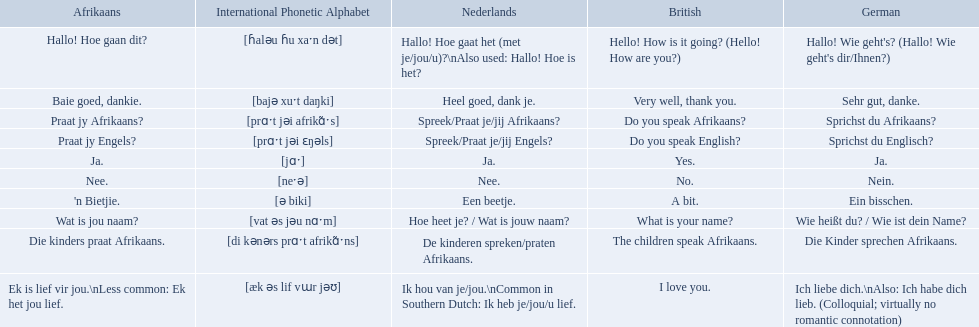What are the listed afrikaans phrases? Hallo! Hoe gaan dit?, Baie goed, dankie., Praat jy Afrikaans?, Praat jy Engels?, Ja., Nee., 'n Bietjie., Wat is jou naam?, Die kinders praat Afrikaans., Ek is lief vir jou.\nLess common: Ek het jou lief. Which is die kinders praat afrikaans? Die kinders praat Afrikaans. Can you give me this table as a dict? {'header': ['Afrikaans', 'International Phonetic Alphabet', 'Nederlands', 'British', 'German'], 'rows': [['Hallo! Hoe gaan dit?', '[ɦaləu ɦu xaˑn dət]', 'Hallo! Hoe gaat het (met je/jou/u)?\\nAlso used: Hallo! Hoe is het?', 'Hello! How is it going? (Hello! How are you?)', "Hallo! Wie geht's? (Hallo! Wie geht's dir/Ihnen?)"], ['Baie goed, dankie.', '[bajə xuˑt daŋki]', 'Heel goed, dank je.', 'Very well, thank you.', 'Sehr gut, danke.'], ['Praat jy Afrikaans?', '[prɑˑt jəi afrikɑ̃ˑs]', 'Spreek/Praat je/jij Afrikaans?', 'Do you speak Afrikaans?', 'Sprichst du Afrikaans?'], ['Praat jy Engels?', '[prɑˑt jəi ɛŋəls]', 'Spreek/Praat je/jij Engels?', 'Do you speak English?', 'Sprichst du Englisch?'], ['Ja.', '[jɑˑ]', 'Ja.', 'Yes.', 'Ja.'], ['Nee.', '[neˑə]', 'Nee.', 'No.', 'Nein.'], ["'n Bietjie.", '[ə biki]', 'Een beetje.', 'A bit.', 'Ein bisschen.'], ['Wat is jou naam?', '[vat əs jəu nɑˑm]', 'Hoe heet je? / Wat is jouw naam?', 'What is your name?', 'Wie heißt du? / Wie ist dein Name?'], ['Die kinders praat Afrikaans.', '[di kənərs prɑˑt afrikɑ̃ˑns]', 'De kinderen spreken/praten Afrikaans.', 'The children speak Afrikaans.', 'Die Kinder sprechen Afrikaans.'], ['Ek is lief vir jou.\\nLess common: Ek het jou lief.', '[æk əs lif vɯr jəʊ]', 'Ik hou van je/jou.\\nCommon in Southern Dutch: Ik heb je/jou/u lief.', 'I love you.', 'Ich liebe dich.\\nAlso: Ich habe dich lieb. (Colloquial; virtually no romantic connotation)']]} What is its german translation? Die Kinder sprechen Afrikaans. How do you say hello! how is it going? in afrikaans? Hallo! Hoe gaan dit?. How do you say very well, thank you in afrikaans? Baie goed, dankie. How would you say do you speak afrikaans? in afrikaans? Praat jy Afrikaans?. Could you help me parse every detail presented in this table? {'header': ['Afrikaans', 'International Phonetic Alphabet', 'Nederlands', 'British', 'German'], 'rows': [['Hallo! Hoe gaan dit?', '[ɦaləu ɦu xaˑn dət]', 'Hallo! Hoe gaat het (met je/jou/u)?\\nAlso used: Hallo! Hoe is het?', 'Hello! How is it going? (Hello! How are you?)', "Hallo! Wie geht's? (Hallo! Wie geht's dir/Ihnen?)"], ['Baie goed, dankie.', '[bajə xuˑt daŋki]', 'Heel goed, dank je.', 'Very well, thank you.', 'Sehr gut, danke.'], ['Praat jy Afrikaans?', '[prɑˑt jəi afrikɑ̃ˑs]', 'Spreek/Praat je/jij Afrikaans?', 'Do you speak Afrikaans?', 'Sprichst du Afrikaans?'], ['Praat jy Engels?', '[prɑˑt jəi ɛŋəls]', 'Spreek/Praat je/jij Engels?', 'Do you speak English?', 'Sprichst du Englisch?'], ['Ja.', '[jɑˑ]', 'Ja.', 'Yes.', 'Ja.'], ['Nee.', '[neˑə]', 'Nee.', 'No.', 'Nein.'], ["'n Bietjie.", '[ə biki]', 'Een beetje.', 'A bit.', 'Ein bisschen.'], ['Wat is jou naam?', '[vat əs jəu nɑˑm]', 'Hoe heet je? / Wat is jouw naam?', 'What is your name?', 'Wie heißt du? / Wie ist dein Name?'], ['Die kinders praat Afrikaans.', '[di kənərs prɑˑt afrikɑ̃ˑns]', 'De kinderen spreken/praten Afrikaans.', 'The children speak Afrikaans.', 'Die Kinder sprechen Afrikaans.'], ['Ek is lief vir jou.\\nLess common: Ek het jou lief.', '[æk əs lif vɯr jəʊ]', 'Ik hou van je/jou.\\nCommon in Southern Dutch: Ik heb je/jou/u lief.', 'I love you.', 'Ich liebe dich.\\nAlso: Ich habe dich lieb. (Colloquial; virtually no romantic connotation)']]} Which phrases are said in africaans? Hallo! Hoe gaan dit?, Baie goed, dankie., Praat jy Afrikaans?, Praat jy Engels?, Ja., Nee., 'n Bietjie., Wat is jou naam?, Die kinders praat Afrikaans., Ek is lief vir jou.\nLess common: Ek het jou lief. Which of these mean how do you speak afrikaans? Praat jy Afrikaans?. What are all of the afrikaans phrases in the list? Hallo! Hoe gaan dit?, Baie goed, dankie., Praat jy Afrikaans?, Praat jy Engels?, Ja., Nee., 'n Bietjie., Wat is jou naam?, Die kinders praat Afrikaans., Ek is lief vir jou.\nLess common: Ek het jou lief. What is the english translation of each phrase? Hello! How is it going? (Hello! How are you?), Very well, thank you., Do you speak Afrikaans?, Do you speak English?, Yes., No., A bit., What is your name?, The children speak Afrikaans., I love you. And which afrikaans phrase translated to do you speak afrikaans? Praat jy Afrikaans?. 